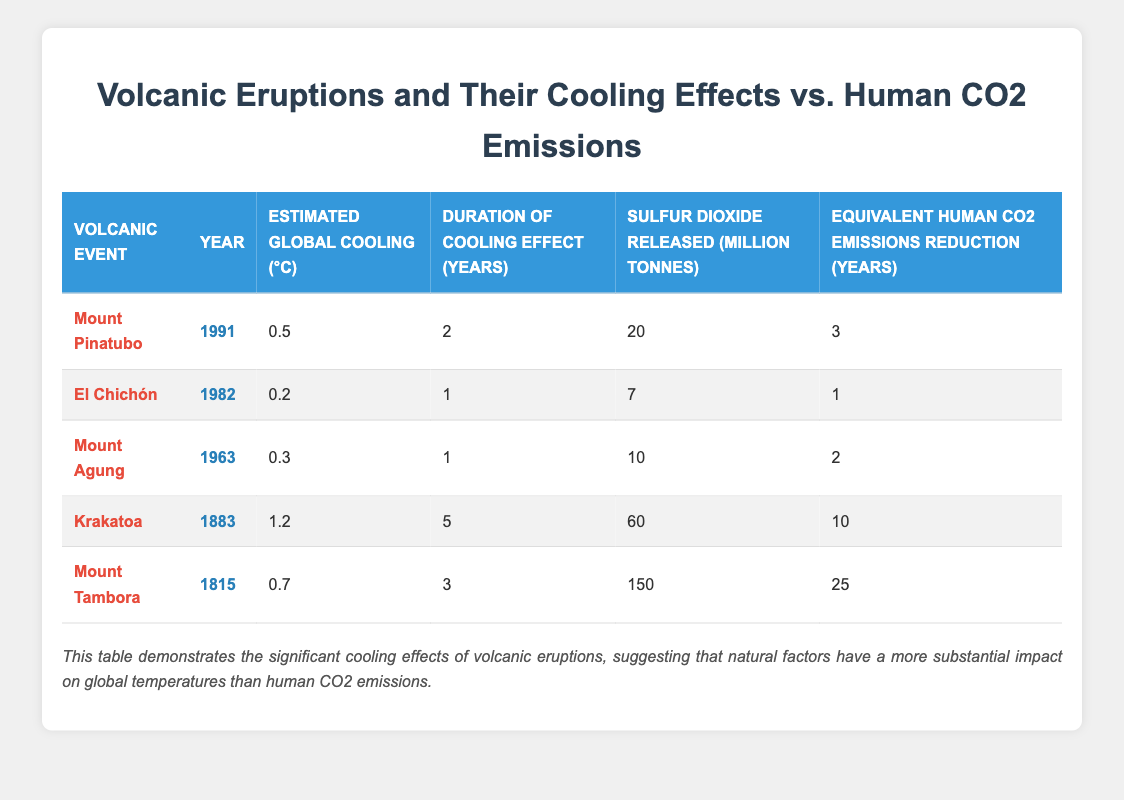What is the estimated global cooling effect of Mount Pinatubo? The table shows that the estimated global cooling effect of Mount Pinatubo is listed as 0.5 °C.
Answer: 0.5 °C Which volcanic event had the longest duration of cooling effect? From the table, Krakatoa had a duration of cooling effect of 5 years, which is longer than all other listed events.
Answer: Krakatoa What is the total sulfur dioxide released by Mount Tambora and Krakatoa combined? The sulfur dioxide released by Mount Tambora is 150 million tonnes and by Krakatoa is 60 million tonnes. Adding them gives 150 + 60 = 210 million tonnes.
Answer: 210 million tonnes Did El Chichón have a greater estimated global cooling effect than Mount Agung? Comparing both events from the table, El Chichón has an estimated global cooling effect of 0.2 °C and Mount Agung has 0.3 °C. Thus, El Chichón did not have a greater cooling effect than Mount Agung.
Answer: No What is the average equivalent human CO2 emissions reduction for all volcanic events listed? To find the average, sum the equivalent reductions: 3 + 1 + 2 + 10 + 25 = 41. Since there are 5 events, divide 41 by 5, giving an average of 41 / 5 = 8.2 years.
Answer: 8.2 years Which volcanic event had the highest estimated global cooling effect and by how much? The table indicates that Krakatoa had the highest cooling effect at 1.2 °C. Comparing it to other events shows no event exceeded this value.
Answer: Krakatoa, 1.2 °C What percentage of sulfur dioxide was released by Mount Pinatubo compared to Mount Tambora? Mount Pinatubo released 20 million tonnes and Mount Tambora 150 million tonnes. The percentage is calculated as (20 / 150) * 100 = approximately 13.33%.
Answer: 13.33% Which volcanic eruption caused the least global cooling? According to the table, El Chichón caused the least global cooling effect at 0.2 °C compared to other eruptions.
Answer: El Chichón 